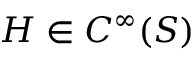<formula> <loc_0><loc_0><loc_500><loc_500>H \in C ^ { \infty } ( S )</formula> 